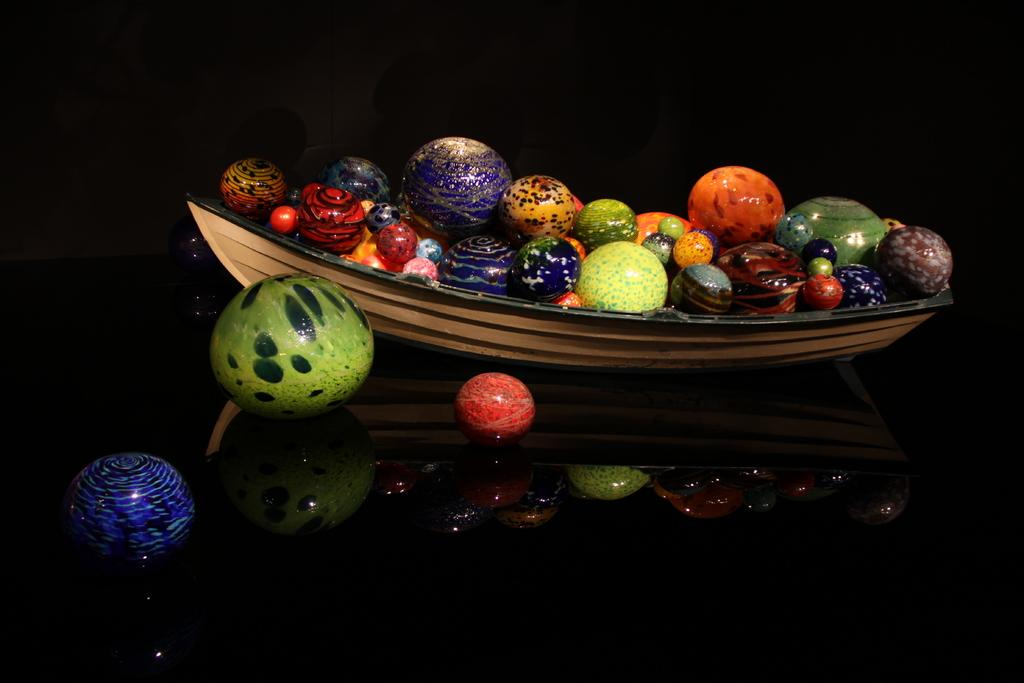What type of objects are in the image? There are colorful balls in the image. Where are the balls located? The balls are in a boat-shaped object. What color is the surface beneath the balls? The surface beneath the balls is black. How does the store compare to the balls in the image? There is no store present in the image, so it cannot be compared to the balls. 